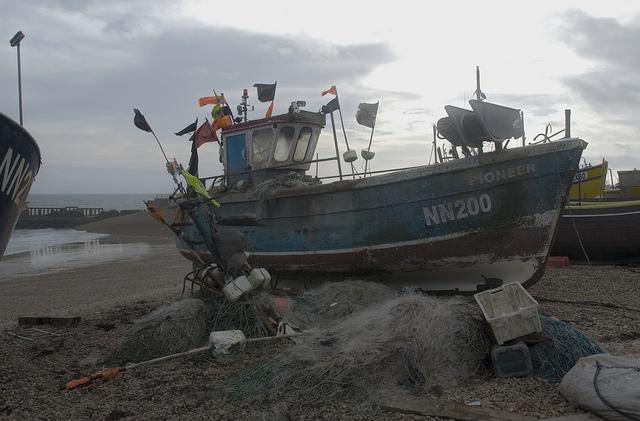What color are most of the flags?
Short answer required. Red. What is the tag number on the boat?
Concise answer only. N200. Is the street paved?
Be succinct. No. What is in the boat?
Write a very short answer. Flags. Is the photo in color?
Answer briefly. Yes. What flag is on the small boat?
Keep it brief. Several. Is this a transportation vehicle?
Write a very short answer. Yes. Is there a motorcycle in the picture?
Write a very short answer. No. How many numbers appear on the side of the ship?
Quick response, please. 3. What is written on the boat?
Concise answer only. Pioneer. How many boats can be seen?
Short answer required. 3. Is this a new boat?
Be succinct. No. Where are the boats sitting?
Keep it brief. Beach. Is the boat in water?
Be succinct. No. Are they in the ocean?
Answer briefly. No. 